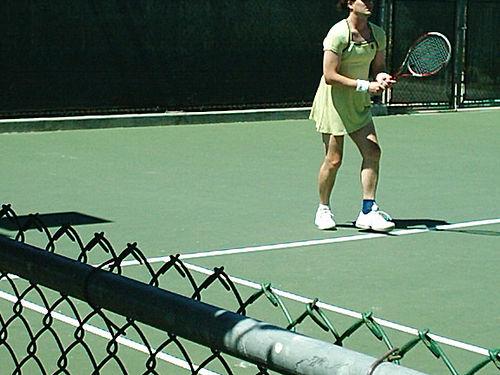Is the woman wearing a tennis outfit?
Be succinct. Yes. What is the person holding?
Short answer required. Tennis racket. What kind of shoes is the person wearing?
Write a very short answer. Tennis shoes. 